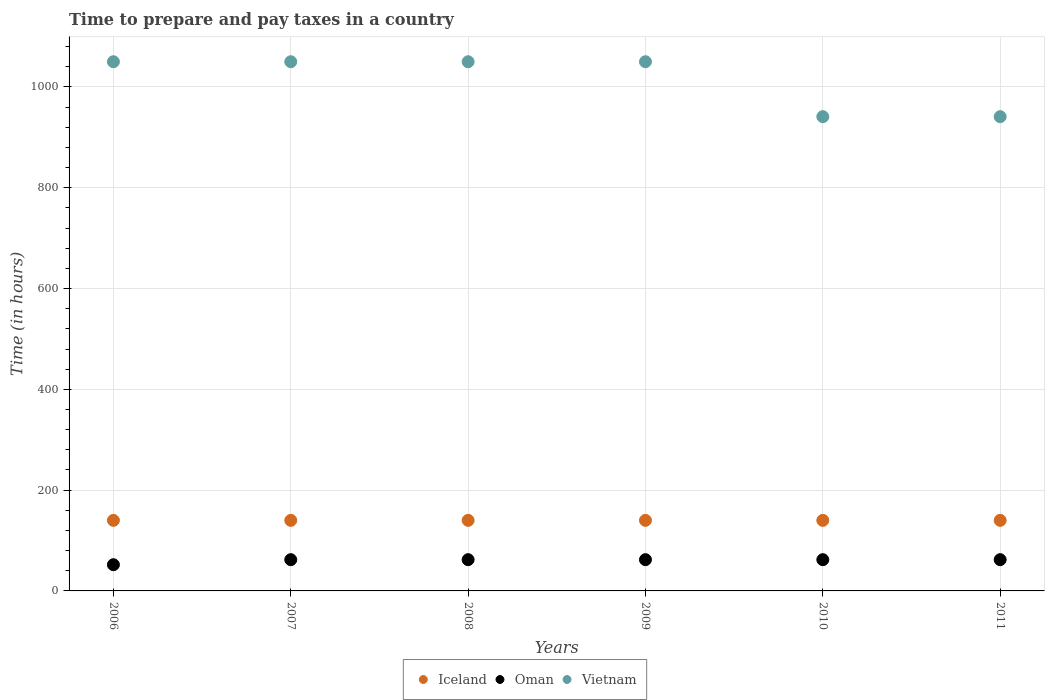What is the number of hours required to prepare and pay taxes in Iceland in 2011?
Your answer should be compact. 140. Across all years, what is the maximum number of hours required to prepare and pay taxes in Vietnam?
Your answer should be compact. 1050. Across all years, what is the minimum number of hours required to prepare and pay taxes in Vietnam?
Offer a very short reply. 941. In which year was the number of hours required to prepare and pay taxes in Iceland maximum?
Provide a succinct answer. 2006. In which year was the number of hours required to prepare and pay taxes in Oman minimum?
Your response must be concise. 2006. What is the total number of hours required to prepare and pay taxes in Vietnam in the graph?
Your answer should be compact. 6082. What is the difference between the number of hours required to prepare and pay taxes in Oman in 2006 and that in 2010?
Provide a succinct answer. -10. What is the difference between the number of hours required to prepare and pay taxes in Oman in 2010 and the number of hours required to prepare and pay taxes in Vietnam in 2008?
Keep it short and to the point. -988. What is the average number of hours required to prepare and pay taxes in Oman per year?
Your answer should be very brief. 60.33. In the year 2006, what is the difference between the number of hours required to prepare and pay taxes in Oman and number of hours required to prepare and pay taxes in Iceland?
Your response must be concise. -88. What is the ratio of the number of hours required to prepare and pay taxes in Vietnam in 2006 to that in 2007?
Offer a terse response. 1. Is the number of hours required to prepare and pay taxes in Vietnam in 2006 less than that in 2011?
Your answer should be very brief. No. Is the difference between the number of hours required to prepare and pay taxes in Oman in 2008 and 2011 greater than the difference between the number of hours required to prepare and pay taxes in Iceland in 2008 and 2011?
Offer a terse response. No. Is the number of hours required to prepare and pay taxes in Iceland strictly less than the number of hours required to prepare and pay taxes in Oman over the years?
Give a very brief answer. No. Are the values on the major ticks of Y-axis written in scientific E-notation?
Make the answer very short. No. Where does the legend appear in the graph?
Ensure brevity in your answer.  Bottom center. How many legend labels are there?
Make the answer very short. 3. What is the title of the graph?
Keep it short and to the point. Time to prepare and pay taxes in a country. Does "Thailand" appear as one of the legend labels in the graph?
Keep it short and to the point. No. What is the label or title of the X-axis?
Offer a very short reply. Years. What is the label or title of the Y-axis?
Make the answer very short. Time (in hours). What is the Time (in hours) of Iceland in 2006?
Make the answer very short. 140. What is the Time (in hours) in Oman in 2006?
Keep it short and to the point. 52. What is the Time (in hours) of Vietnam in 2006?
Your response must be concise. 1050. What is the Time (in hours) of Iceland in 2007?
Ensure brevity in your answer.  140. What is the Time (in hours) of Vietnam in 2007?
Your answer should be very brief. 1050. What is the Time (in hours) in Iceland in 2008?
Make the answer very short. 140. What is the Time (in hours) in Oman in 2008?
Keep it short and to the point. 62. What is the Time (in hours) in Vietnam in 2008?
Provide a succinct answer. 1050. What is the Time (in hours) of Iceland in 2009?
Provide a succinct answer. 140. What is the Time (in hours) of Oman in 2009?
Provide a succinct answer. 62. What is the Time (in hours) in Vietnam in 2009?
Your response must be concise. 1050. What is the Time (in hours) of Iceland in 2010?
Offer a very short reply. 140. What is the Time (in hours) of Oman in 2010?
Make the answer very short. 62. What is the Time (in hours) in Vietnam in 2010?
Provide a succinct answer. 941. What is the Time (in hours) of Iceland in 2011?
Offer a very short reply. 140. What is the Time (in hours) in Vietnam in 2011?
Your answer should be very brief. 941. Across all years, what is the maximum Time (in hours) in Iceland?
Provide a succinct answer. 140. Across all years, what is the maximum Time (in hours) in Vietnam?
Provide a short and direct response. 1050. Across all years, what is the minimum Time (in hours) of Iceland?
Offer a very short reply. 140. Across all years, what is the minimum Time (in hours) in Vietnam?
Offer a terse response. 941. What is the total Time (in hours) of Iceland in the graph?
Provide a short and direct response. 840. What is the total Time (in hours) of Oman in the graph?
Offer a very short reply. 362. What is the total Time (in hours) of Vietnam in the graph?
Offer a very short reply. 6082. What is the difference between the Time (in hours) in Iceland in 2006 and that in 2007?
Ensure brevity in your answer.  0. What is the difference between the Time (in hours) of Vietnam in 2006 and that in 2007?
Offer a very short reply. 0. What is the difference between the Time (in hours) in Iceland in 2006 and that in 2008?
Your response must be concise. 0. What is the difference between the Time (in hours) in Vietnam in 2006 and that in 2008?
Your answer should be compact. 0. What is the difference between the Time (in hours) in Iceland in 2006 and that in 2009?
Make the answer very short. 0. What is the difference between the Time (in hours) of Oman in 2006 and that in 2009?
Your answer should be very brief. -10. What is the difference between the Time (in hours) in Vietnam in 2006 and that in 2009?
Your answer should be very brief. 0. What is the difference between the Time (in hours) in Oman in 2006 and that in 2010?
Offer a terse response. -10. What is the difference between the Time (in hours) of Vietnam in 2006 and that in 2010?
Provide a succinct answer. 109. What is the difference between the Time (in hours) in Iceland in 2006 and that in 2011?
Provide a succinct answer. 0. What is the difference between the Time (in hours) of Vietnam in 2006 and that in 2011?
Your response must be concise. 109. What is the difference between the Time (in hours) in Vietnam in 2007 and that in 2008?
Make the answer very short. 0. What is the difference between the Time (in hours) of Iceland in 2007 and that in 2009?
Your response must be concise. 0. What is the difference between the Time (in hours) in Oman in 2007 and that in 2009?
Provide a short and direct response. 0. What is the difference between the Time (in hours) in Vietnam in 2007 and that in 2009?
Offer a terse response. 0. What is the difference between the Time (in hours) in Iceland in 2007 and that in 2010?
Your response must be concise. 0. What is the difference between the Time (in hours) of Oman in 2007 and that in 2010?
Offer a very short reply. 0. What is the difference between the Time (in hours) in Vietnam in 2007 and that in 2010?
Give a very brief answer. 109. What is the difference between the Time (in hours) in Oman in 2007 and that in 2011?
Keep it short and to the point. 0. What is the difference between the Time (in hours) of Vietnam in 2007 and that in 2011?
Your answer should be very brief. 109. What is the difference between the Time (in hours) of Oman in 2008 and that in 2009?
Your response must be concise. 0. What is the difference between the Time (in hours) in Vietnam in 2008 and that in 2009?
Your answer should be very brief. 0. What is the difference between the Time (in hours) of Vietnam in 2008 and that in 2010?
Your answer should be very brief. 109. What is the difference between the Time (in hours) of Iceland in 2008 and that in 2011?
Your answer should be very brief. 0. What is the difference between the Time (in hours) of Vietnam in 2008 and that in 2011?
Your answer should be compact. 109. What is the difference between the Time (in hours) in Oman in 2009 and that in 2010?
Keep it short and to the point. 0. What is the difference between the Time (in hours) in Vietnam in 2009 and that in 2010?
Your answer should be very brief. 109. What is the difference between the Time (in hours) in Iceland in 2009 and that in 2011?
Give a very brief answer. 0. What is the difference between the Time (in hours) of Vietnam in 2009 and that in 2011?
Offer a terse response. 109. What is the difference between the Time (in hours) of Iceland in 2006 and the Time (in hours) of Oman in 2007?
Give a very brief answer. 78. What is the difference between the Time (in hours) of Iceland in 2006 and the Time (in hours) of Vietnam in 2007?
Provide a short and direct response. -910. What is the difference between the Time (in hours) in Oman in 2006 and the Time (in hours) in Vietnam in 2007?
Provide a short and direct response. -998. What is the difference between the Time (in hours) in Iceland in 2006 and the Time (in hours) in Oman in 2008?
Give a very brief answer. 78. What is the difference between the Time (in hours) in Iceland in 2006 and the Time (in hours) in Vietnam in 2008?
Provide a short and direct response. -910. What is the difference between the Time (in hours) in Oman in 2006 and the Time (in hours) in Vietnam in 2008?
Provide a succinct answer. -998. What is the difference between the Time (in hours) in Iceland in 2006 and the Time (in hours) in Vietnam in 2009?
Your answer should be compact. -910. What is the difference between the Time (in hours) in Oman in 2006 and the Time (in hours) in Vietnam in 2009?
Offer a very short reply. -998. What is the difference between the Time (in hours) in Iceland in 2006 and the Time (in hours) in Vietnam in 2010?
Make the answer very short. -801. What is the difference between the Time (in hours) of Oman in 2006 and the Time (in hours) of Vietnam in 2010?
Your response must be concise. -889. What is the difference between the Time (in hours) in Iceland in 2006 and the Time (in hours) in Oman in 2011?
Provide a short and direct response. 78. What is the difference between the Time (in hours) of Iceland in 2006 and the Time (in hours) of Vietnam in 2011?
Your answer should be compact. -801. What is the difference between the Time (in hours) of Oman in 2006 and the Time (in hours) of Vietnam in 2011?
Offer a terse response. -889. What is the difference between the Time (in hours) in Iceland in 2007 and the Time (in hours) in Oman in 2008?
Your answer should be very brief. 78. What is the difference between the Time (in hours) in Iceland in 2007 and the Time (in hours) in Vietnam in 2008?
Your response must be concise. -910. What is the difference between the Time (in hours) of Oman in 2007 and the Time (in hours) of Vietnam in 2008?
Provide a short and direct response. -988. What is the difference between the Time (in hours) of Iceland in 2007 and the Time (in hours) of Oman in 2009?
Give a very brief answer. 78. What is the difference between the Time (in hours) in Iceland in 2007 and the Time (in hours) in Vietnam in 2009?
Make the answer very short. -910. What is the difference between the Time (in hours) in Oman in 2007 and the Time (in hours) in Vietnam in 2009?
Give a very brief answer. -988. What is the difference between the Time (in hours) of Iceland in 2007 and the Time (in hours) of Oman in 2010?
Offer a terse response. 78. What is the difference between the Time (in hours) of Iceland in 2007 and the Time (in hours) of Vietnam in 2010?
Keep it short and to the point. -801. What is the difference between the Time (in hours) in Oman in 2007 and the Time (in hours) in Vietnam in 2010?
Provide a short and direct response. -879. What is the difference between the Time (in hours) of Iceland in 2007 and the Time (in hours) of Oman in 2011?
Your response must be concise. 78. What is the difference between the Time (in hours) in Iceland in 2007 and the Time (in hours) in Vietnam in 2011?
Offer a very short reply. -801. What is the difference between the Time (in hours) of Oman in 2007 and the Time (in hours) of Vietnam in 2011?
Your response must be concise. -879. What is the difference between the Time (in hours) of Iceland in 2008 and the Time (in hours) of Vietnam in 2009?
Give a very brief answer. -910. What is the difference between the Time (in hours) in Oman in 2008 and the Time (in hours) in Vietnam in 2009?
Make the answer very short. -988. What is the difference between the Time (in hours) of Iceland in 2008 and the Time (in hours) of Oman in 2010?
Provide a short and direct response. 78. What is the difference between the Time (in hours) of Iceland in 2008 and the Time (in hours) of Vietnam in 2010?
Give a very brief answer. -801. What is the difference between the Time (in hours) in Oman in 2008 and the Time (in hours) in Vietnam in 2010?
Ensure brevity in your answer.  -879. What is the difference between the Time (in hours) in Iceland in 2008 and the Time (in hours) in Oman in 2011?
Your response must be concise. 78. What is the difference between the Time (in hours) of Iceland in 2008 and the Time (in hours) of Vietnam in 2011?
Your answer should be compact. -801. What is the difference between the Time (in hours) in Oman in 2008 and the Time (in hours) in Vietnam in 2011?
Your response must be concise. -879. What is the difference between the Time (in hours) in Iceland in 2009 and the Time (in hours) in Oman in 2010?
Make the answer very short. 78. What is the difference between the Time (in hours) in Iceland in 2009 and the Time (in hours) in Vietnam in 2010?
Offer a terse response. -801. What is the difference between the Time (in hours) in Oman in 2009 and the Time (in hours) in Vietnam in 2010?
Offer a very short reply. -879. What is the difference between the Time (in hours) in Iceland in 2009 and the Time (in hours) in Oman in 2011?
Your answer should be very brief. 78. What is the difference between the Time (in hours) of Iceland in 2009 and the Time (in hours) of Vietnam in 2011?
Keep it short and to the point. -801. What is the difference between the Time (in hours) in Oman in 2009 and the Time (in hours) in Vietnam in 2011?
Offer a very short reply. -879. What is the difference between the Time (in hours) in Iceland in 2010 and the Time (in hours) in Vietnam in 2011?
Offer a very short reply. -801. What is the difference between the Time (in hours) of Oman in 2010 and the Time (in hours) of Vietnam in 2011?
Your answer should be compact. -879. What is the average Time (in hours) of Iceland per year?
Give a very brief answer. 140. What is the average Time (in hours) of Oman per year?
Offer a terse response. 60.33. What is the average Time (in hours) in Vietnam per year?
Your answer should be very brief. 1013.67. In the year 2006, what is the difference between the Time (in hours) of Iceland and Time (in hours) of Oman?
Offer a terse response. 88. In the year 2006, what is the difference between the Time (in hours) of Iceland and Time (in hours) of Vietnam?
Your response must be concise. -910. In the year 2006, what is the difference between the Time (in hours) in Oman and Time (in hours) in Vietnam?
Your response must be concise. -998. In the year 2007, what is the difference between the Time (in hours) in Iceland and Time (in hours) in Oman?
Provide a succinct answer. 78. In the year 2007, what is the difference between the Time (in hours) of Iceland and Time (in hours) of Vietnam?
Provide a succinct answer. -910. In the year 2007, what is the difference between the Time (in hours) of Oman and Time (in hours) of Vietnam?
Provide a succinct answer. -988. In the year 2008, what is the difference between the Time (in hours) in Iceland and Time (in hours) in Vietnam?
Offer a terse response. -910. In the year 2008, what is the difference between the Time (in hours) in Oman and Time (in hours) in Vietnam?
Offer a terse response. -988. In the year 2009, what is the difference between the Time (in hours) in Iceland and Time (in hours) in Oman?
Ensure brevity in your answer.  78. In the year 2009, what is the difference between the Time (in hours) in Iceland and Time (in hours) in Vietnam?
Your response must be concise. -910. In the year 2009, what is the difference between the Time (in hours) in Oman and Time (in hours) in Vietnam?
Give a very brief answer. -988. In the year 2010, what is the difference between the Time (in hours) in Iceland and Time (in hours) in Vietnam?
Your answer should be very brief. -801. In the year 2010, what is the difference between the Time (in hours) in Oman and Time (in hours) in Vietnam?
Keep it short and to the point. -879. In the year 2011, what is the difference between the Time (in hours) of Iceland and Time (in hours) of Oman?
Your answer should be compact. 78. In the year 2011, what is the difference between the Time (in hours) in Iceland and Time (in hours) in Vietnam?
Provide a short and direct response. -801. In the year 2011, what is the difference between the Time (in hours) in Oman and Time (in hours) in Vietnam?
Offer a very short reply. -879. What is the ratio of the Time (in hours) of Iceland in 2006 to that in 2007?
Offer a very short reply. 1. What is the ratio of the Time (in hours) of Oman in 2006 to that in 2007?
Provide a short and direct response. 0.84. What is the ratio of the Time (in hours) in Vietnam in 2006 to that in 2007?
Offer a very short reply. 1. What is the ratio of the Time (in hours) in Iceland in 2006 to that in 2008?
Offer a very short reply. 1. What is the ratio of the Time (in hours) in Oman in 2006 to that in 2008?
Keep it short and to the point. 0.84. What is the ratio of the Time (in hours) in Iceland in 2006 to that in 2009?
Offer a terse response. 1. What is the ratio of the Time (in hours) in Oman in 2006 to that in 2009?
Keep it short and to the point. 0.84. What is the ratio of the Time (in hours) in Vietnam in 2006 to that in 2009?
Offer a terse response. 1. What is the ratio of the Time (in hours) in Iceland in 2006 to that in 2010?
Provide a short and direct response. 1. What is the ratio of the Time (in hours) in Oman in 2006 to that in 2010?
Provide a succinct answer. 0.84. What is the ratio of the Time (in hours) of Vietnam in 2006 to that in 2010?
Your answer should be very brief. 1.12. What is the ratio of the Time (in hours) in Oman in 2006 to that in 2011?
Provide a succinct answer. 0.84. What is the ratio of the Time (in hours) of Vietnam in 2006 to that in 2011?
Your answer should be very brief. 1.12. What is the ratio of the Time (in hours) of Vietnam in 2007 to that in 2008?
Provide a succinct answer. 1. What is the ratio of the Time (in hours) of Iceland in 2007 to that in 2009?
Offer a terse response. 1. What is the ratio of the Time (in hours) in Iceland in 2007 to that in 2010?
Your answer should be compact. 1. What is the ratio of the Time (in hours) of Vietnam in 2007 to that in 2010?
Your answer should be very brief. 1.12. What is the ratio of the Time (in hours) of Iceland in 2007 to that in 2011?
Give a very brief answer. 1. What is the ratio of the Time (in hours) of Vietnam in 2007 to that in 2011?
Offer a very short reply. 1.12. What is the ratio of the Time (in hours) in Oman in 2008 to that in 2009?
Keep it short and to the point. 1. What is the ratio of the Time (in hours) in Vietnam in 2008 to that in 2009?
Ensure brevity in your answer.  1. What is the ratio of the Time (in hours) in Vietnam in 2008 to that in 2010?
Keep it short and to the point. 1.12. What is the ratio of the Time (in hours) of Iceland in 2008 to that in 2011?
Your answer should be very brief. 1. What is the ratio of the Time (in hours) in Oman in 2008 to that in 2011?
Make the answer very short. 1. What is the ratio of the Time (in hours) of Vietnam in 2008 to that in 2011?
Your response must be concise. 1.12. What is the ratio of the Time (in hours) of Vietnam in 2009 to that in 2010?
Provide a short and direct response. 1.12. What is the ratio of the Time (in hours) in Vietnam in 2009 to that in 2011?
Your answer should be compact. 1.12. What is the ratio of the Time (in hours) in Vietnam in 2010 to that in 2011?
Your response must be concise. 1. What is the difference between the highest and the second highest Time (in hours) of Iceland?
Keep it short and to the point. 0. What is the difference between the highest and the lowest Time (in hours) in Iceland?
Make the answer very short. 0. What is the difference between the highest and the lowest Time (in hours) of Vietnam?
Make the answer very short. 109. 